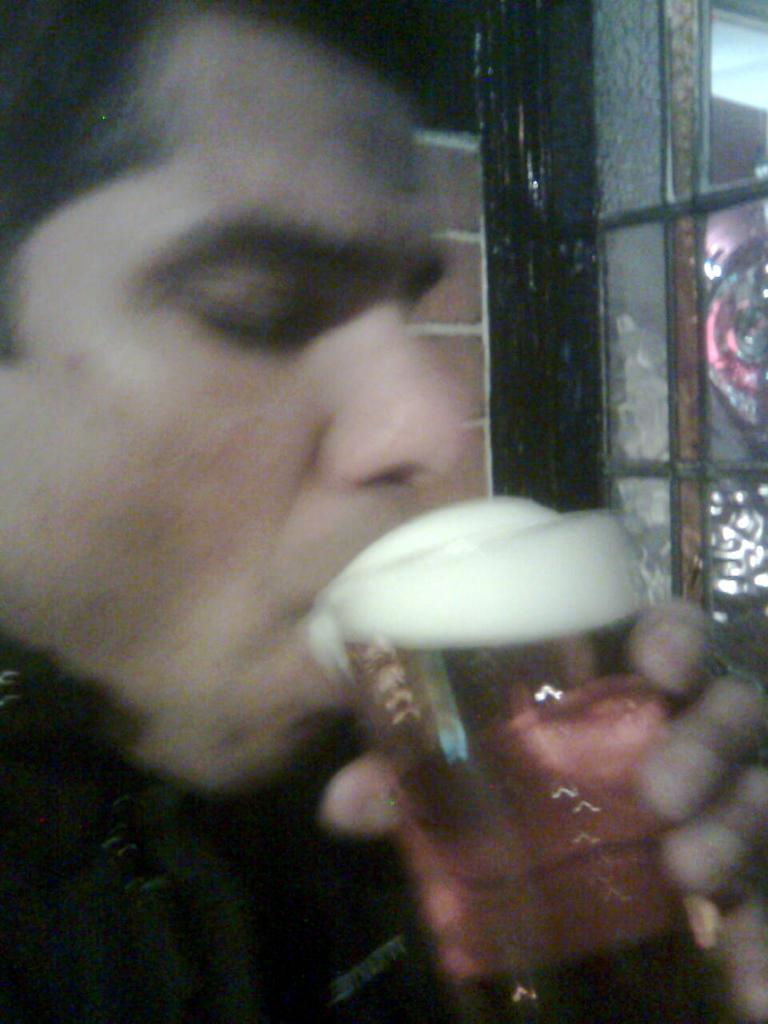Who is present in the image? There is a man in the image. What is the man holding in his hand? The man is holding a glass in his hand. What can be seen in the background of the image? There are glass doors in the background of the image. What type of watch is the man wearing on his wrist in the image? There is no watch visible on the man's wrist in the image. 